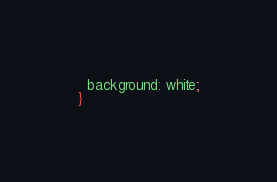Convert code to text. <code><loc_0><loc_0><loc_500><loc_500><_CSS_>  background: white;
}</code> 